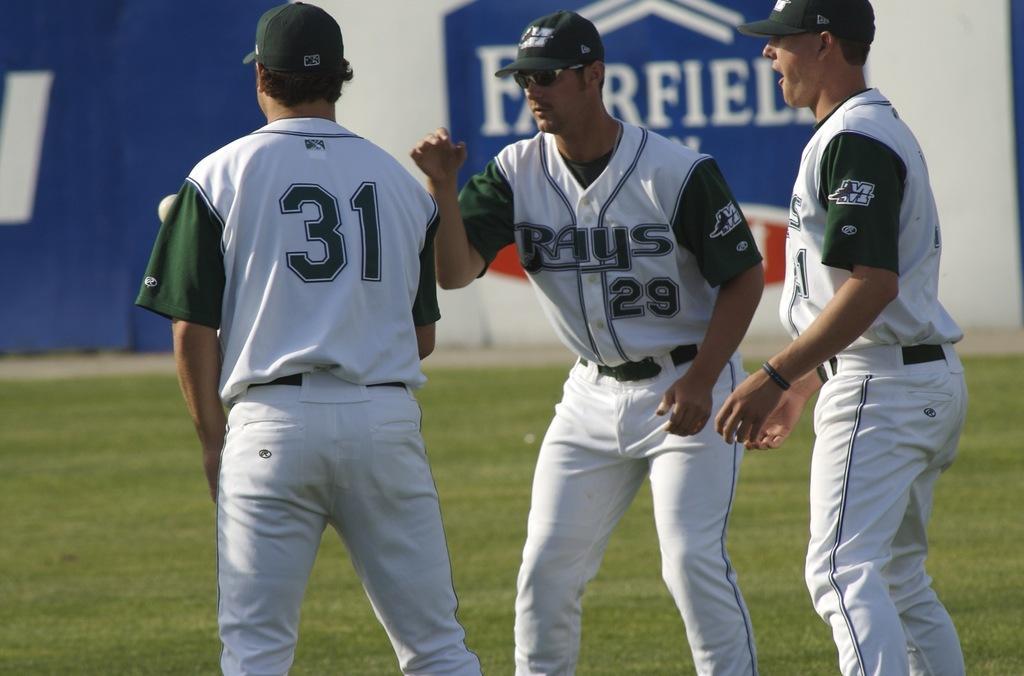Could you give a brief overview of what you see in this image? This picture is clicked outside. In the foreground we can see the group of persons wearing white color t-shirts, green color caps and standing on the ground. The ground is covered with the green grass. In the background there is a wall and we can see a blue color curtain and a banner on which we can see the text is printed. 